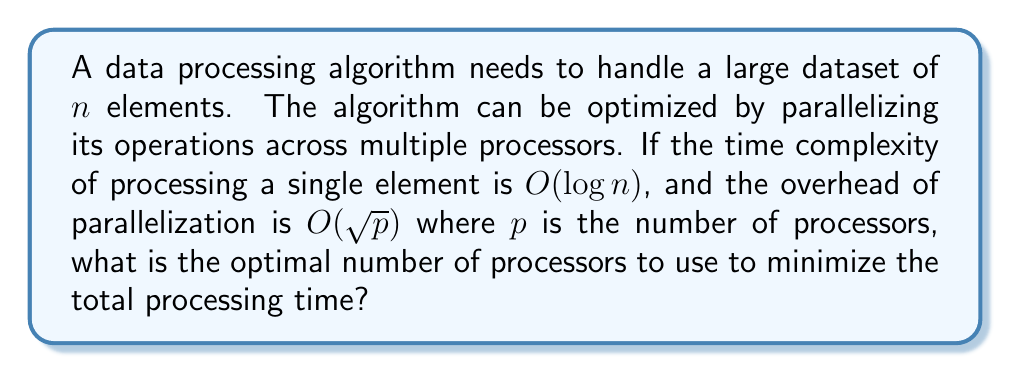Provide a solution to this math problem. Let's approach this step-by-step:

1) The total time complexity of the algorithm can be expressed as:

   $$ T(n,p) = \frac{n \log n}{p} + \sqrt{p} $$

   Where the first term represents the parallel processing time, and the second term represents the parallelization overhead.

2) To find the optimal number of processors, we need to minimize $T(n,p)$ with respect to $p$. We can do this by differentiating $T(n,p)$ with respect to $p$ and setting it to zero:

   $$ \frac{dT}{dp} = -\frac{n \log n}{p^2} + \frac{1}{2\sqrt{p}} = 0 $$

3) Solving this equation:

   $$ -\frac{n \log n}{p^2} + \frac{1}{2\sqrt{p}} = 0 $$
   $$ \frac{n \log n}{p^2} = \frac{1}{2\sqrt{p}} $$
   $$ 2n \log n \sqrt{p} = p^2 $$
   $$ (2n \log n)^2 p = p^4 $$
   $$ p^3 = (2n \log n)^2 $$
   $$ p = (2n \log n)^{2/3} $$

4) To confirm this is a minimum, we can check the second derivative is positive:

   $$ \frac{d^2T}{dp^2} = \frac{2n \log n}{p^3} - \frac{1}{4p^{3/2}} > 0 \text{ for } p > 0 $$

5) Therefore, the optimal number of processors is:

   $$ p_{opt} = (2n \log n)^{2/3} $$

This result is consistent with our skeptical, data-driven persona, as it's derived purely from mathematical optimization without relying on any supernatural concepts.
Answer: $p_{opt} = (2n \log n)^{2/3}$ 